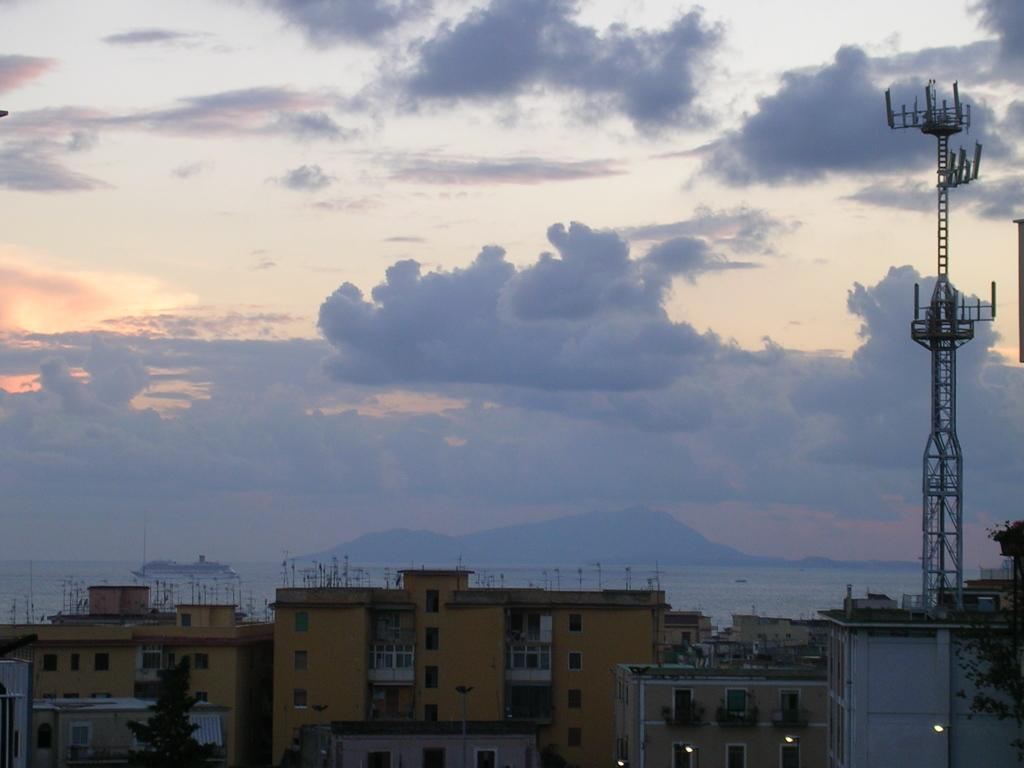What type of structures are located in front of the image? There are buildings in front of the image. Can you describe the structure on the right side of the image? There is a tower on the right side of the image. What is visible in the background of the image? The sky is visible in the background of the image. How would you describe the weather based on the appearance of the sky? The sky appears to be cloudy, which might suggest overcast or potentially rainy weather. Where is the brush used for painting in the image? There is no brush visible in the image. What type of cheese is being served on the table in the image? There is no cheese or table present in the image. 